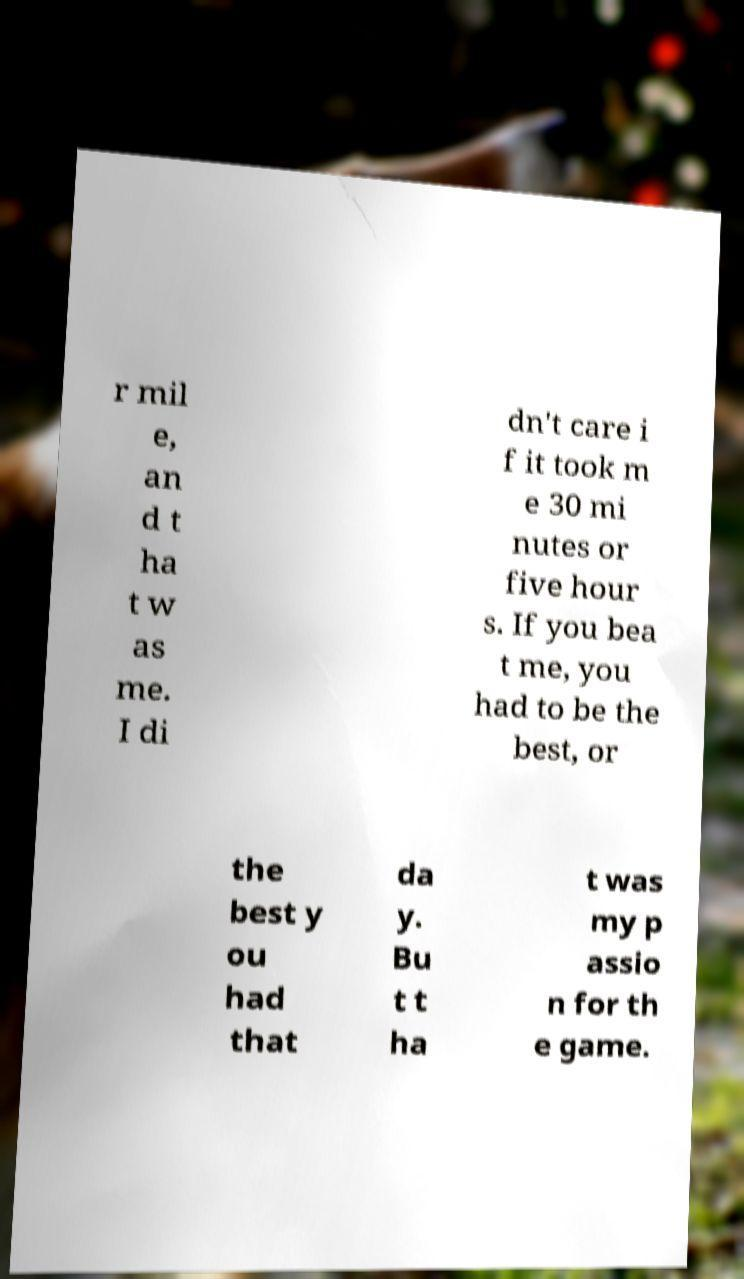What messages or text are displayed in this image? I need them in a readable, typed format. r mil e, an d t ha t w as me. I di dn't care i f it took m e 30 mi nutes or five hour s. If you bea t me, you had to be the best, or the best y ou had that da y. Bu t t ha t was my p assio n for th e game. 